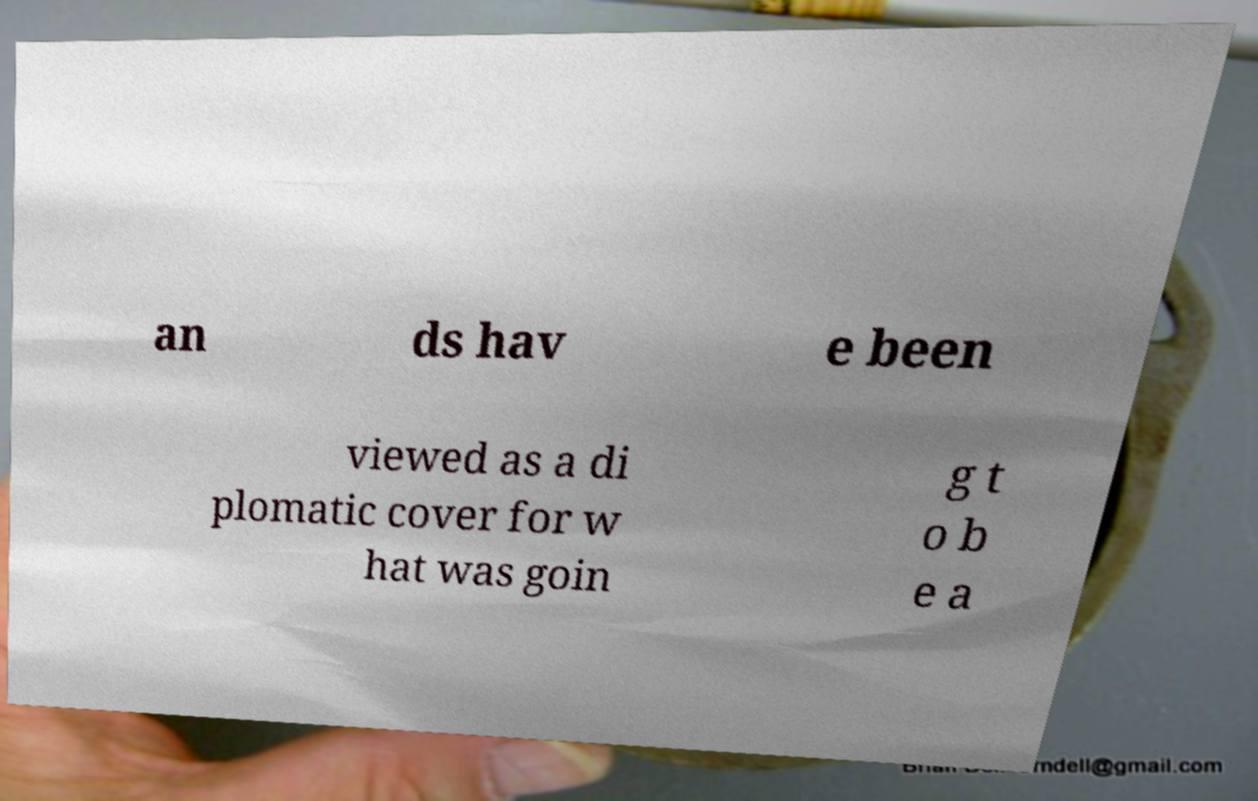Can you accurately transcribe the text from the provided image for me? an ds hav e been viewed as a di plomatic cover for w hat was goin g t o b e a 